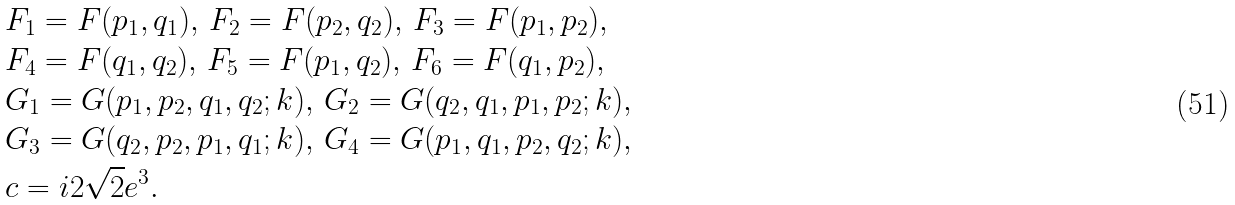Convert formula to latex. <formula><loc_0><loc_0><loc_500><loc_500>& F _ { 1 } = F ( p _ { 1 } , q _ { 1 } ) , \, F _ { 2 } = F ( p _ { 2 } , q _ { 2 } ) , \, F _ { 3 } = F ( p _ { 1 } , p _ { 2 } ) , \\ & F _ { 4 } = F ( q _ { 1 } , q _ { 2 } ) , \, F _ { 5 } = F ( p _ { 1 } , q _ { 2 } ) , \, F _ { 6 } = F ( q _ { 1 } , p _ { 2 } ) , \\ & G _ { 1 } = G ( p _ { 1 } , p _ { 2 } , q _ { 1 } , q _ { 2 } ; k ) , \, G _ { 2 } = G ( q _ { 2 } , q _ { 1 } , p _ { 1 } , p _ { 2 } ; k ) , \\ & G _ { 3 } = G ( q _ { 2 } , p _ { 2 } , p _ { 1 } , q _ { 1 } ; k ) , \, G _ { 4 } = G ( p _ { 1 } , q _ { 1 } , p _ { 2 } , q _ { 2 } ; k ) , \\ & c = i 2 \sqrt { 2 } e ^ { 3 } .</formula> 